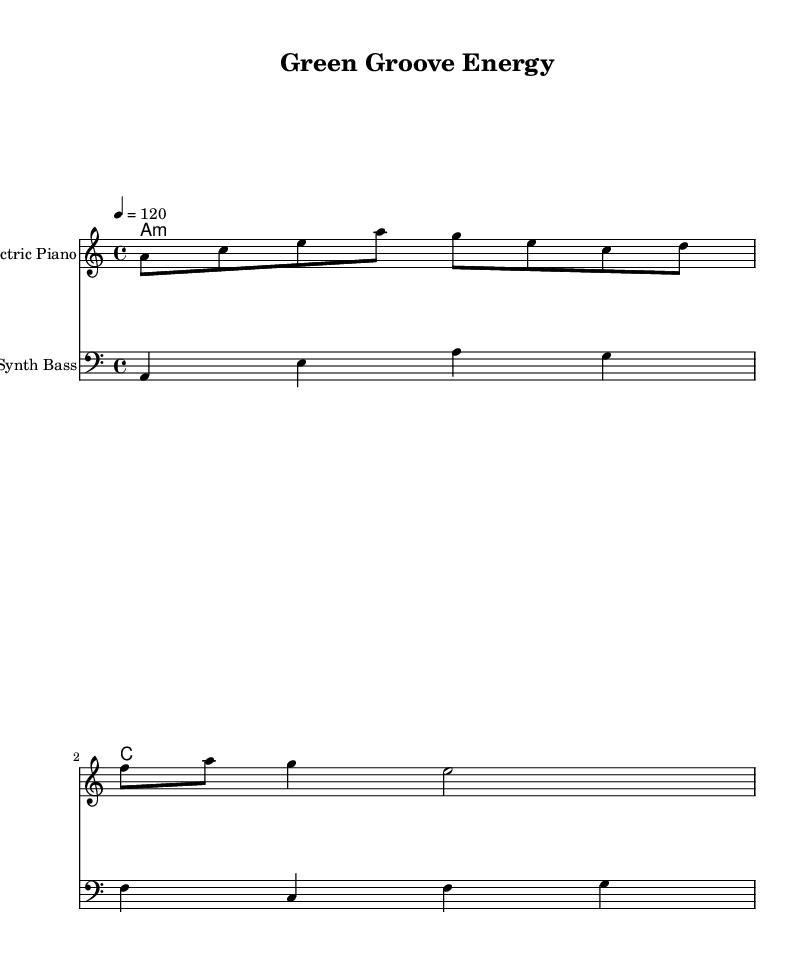What is the key signature of this music? The key signature is A minor, which is identified by having no sharps or flats. This is confirmed by the presence of the A note below the treble staff at the beginning of the score.
Answer: A minor What is the time signature of this music? The time signature is 4/4, which indicates that there are four beats in each measure and the quarter note gets one beat. This is specified at the beginning of the sheet music.
Answer: 4/4 What is the tempo marking in this sheet music? The tempo marking is 4 = 120, which indicates that there are 120 beats per minute, and these can be counted as quarter-note beats. This is noted in the header of the score.
Answer: 120 How many measures are there in the melody? There are three measures in the melody. This is determined by counting the individual staff groups separated by vertical lines, which indicate the end of each measure.
Answer: Three What instrument is indicated for the melody? The instrument indicated for the melody is an Electric Piano. This is specified at the beginning of the staff labeled with the instrument name.
Answer: Electric Piano What chord is played in the first measure of the harmonies? The chord played in the first measure of the harmonies is A minor. This is found by recognizing the chord name 'a:m' directly in the harmony section of the score, indicating an A minor chord.
Answer: A minor What is the rhythm pattern of the bass line in the first measure? The rhythm pattern of the bass line in the first measure consists of four quarter notes, which gives a steady rhythm often found in Disco music. The notes played are a, e, a, and g, all being quarter notes.
Answer: Four quarter notes 